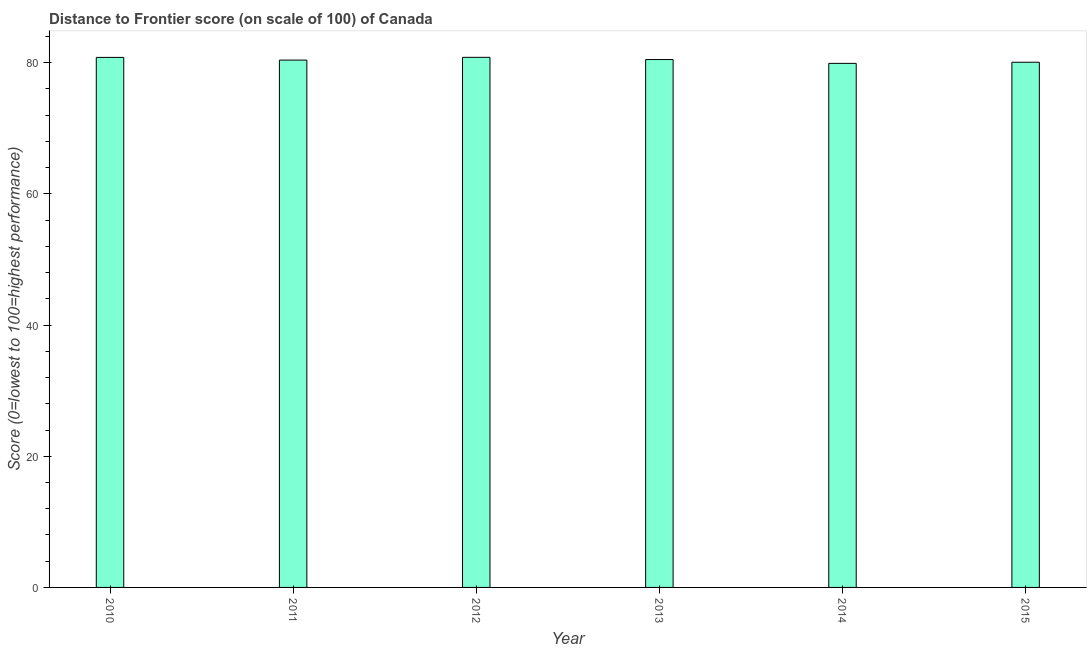Does the graph contain grids?
Keep it short and to the point. No. What is the title of the graph?
Provide a short and direct response. Distance to Frontier score (on scale of 100) of Canada. What is the label or title of the X-axis?
Keep it short and to the point. Year. What is the label or title of the Y-axis?
Offer a terse response. Score (0=lowest to 100=highest performance). What is the distance to frontier score in 2012?
Your answer should be compact. 80.82. Across all years, what is the maximum distance to frontier score?
Keep it short and to the point. 80.82. Across all years, what is the minimum distance to frontier score?
Make the answer very short. 79.9. In which year was the distance to frontier score maximum?
Your answer should be very brief. 2012. What is the sum of the distance to frontier score?
Your answer should be very brief. 482.48. What is the difference between the distance to frontier score in 2011 and 2015?
Offer a terse response. 0.33. What is the average distance to frontier score per year?
Ensure brevity in your answer.  80.41. What is the median distance to frontier score?
Keep it short and to the point. 80.44. In how many years, is the distance to frontier score greater than 80 ?
Make the answer very short. 5. Do a majority of the years between 2013 and 2012 (inclusive) have distance to frontier score greater than 80 ?
Make the answer very short. No. What is the ratio of the distance to frontier score in 2010 to that in 2013?
Offer a very short reply. 1. Is the sum of the distance to frontier score in 2010 and 2014 greater than the maximum distance to frontier score across all years?
Provide a short and direct response. Yes. What is the difference between the highest and the lowest distance to frontier score?
Provide a short and direct response. 0.92. Are all the bars in the graph horizontal?
Provide a short and direct response. No. How many years are there in the graph?
Your answer should be compact. 6. What is the Score (0=lowest to 100=highest performance) of 2010?
Make the answer very short. 80.81. What is the Score (0=lowest to 100=highest performance) of 2011?
Provide a short and direct response. 80.4. What is the Score (0=lowest to 100=highest performance) of 2012?
Your response must be concise. 80.82. What is the Score (0=lowest to 100=highest performance) of 2013?
Provide a short and direct response. 80.48. What is the Score (0=lowest to 100=highest performance) in 2014?
Ensure brevity in your answer.  79.9. What is the Score (0=lowest to 100=highest performance) of 2015?
Offer a terse response. 80.07. What is the difference between the Score (0=lowest to 100=highest performance) in 2010 and 2011?
Your answer should be compact. 0.41. What is the difference between the Score (0=lowest to 100=highest performance) in 2010 and 2012?
Make the answer very short. -0.01. What is the difference between the Score (0=lowest to 100=highest performance) in 2010 and 2013?
Ensure brevity in your answer.  0.33. What is the difference between the Score (0=lowest to 100=highest performance) in 2010 and 2014?
Offer a terse response. 0.91. What is the difference between the Score (0=lowest to 100=highest performance) in 2010 and 2015?
Make the answer very short. 0.74. What is the difference between the Score (0=lowest to 100=highest performance) in 2011 and 2012?
Provide a short and direct response. -0.42. What is the difference between the Score (0=lowest to 100=highest performance) in 2011 and 2013?
Give a very brief answer. -0.08. What is the difference between the Score (0=lowest to 100=highest performance) in 2011 and 2015?
Give a very brief answer. 0.33. What is the difference between the Score (0=lowest to 100=highest performance) in 2012 and 2013?
Keep it short and to the point. 0.34. What is the difference between the Score (0=lowest to 100=highest performance) in 2012 and 2014?
Provide a short and direct response. 0.92. What is the difference between the Score (0=lowest to 100=highest performance) in 2012 and 2015?
Offer a very short reply. 0.75. What is the difference between the Score (0=lowest to 100=highest performance) in 2013 and 2014?
Keep it short and to the point. 0.58. What is the difference between the Score (0=lowest to 100=highest performance) in 2013 and 2015?
Your answer should be very brief. 0.41. What is the difference between the Score (0=lowest to 100=highest performance) in 2014 and 2015?
Offer a very short reply. -0.17. What is the ratio of the Score (0=lowest to 100=highest performance) in 2010 to that in 2012?
Your answer should be compact. 1. What is the ratio of the Score (0=lowest to 100=highest performance) in 2011 to that in 2012?
Give a very brief answer. 0.99. What is the ratio of the Score (0=lowest to 100=highest performance) in 2011 to that in 2013?
Give a very brief answer. 1. What is the ratio of the Score (0=lowest to 100=highest performance) in 2012 to that in 2013?
Your answer should be compact. 1. What is the ratio of the Score (0=lowest to 100=highest performance) in 2012 to that in 2014?
Provide a succinct answer. 1.01. What is the ratio of the Score (0=lowest to 100=highest performance) in 2012 to that in 2015?
Provide a short and direct response. 1.01. What is the ratio of the Score (0=lowest to 100=highest performance) in 2013 to that in 2014?
Offer a terse response. 1.01. What is the ratio of the Score (0=lowest to 100=highest performance) in 2013 to that in 2015?
Your response must be concise. 1. 